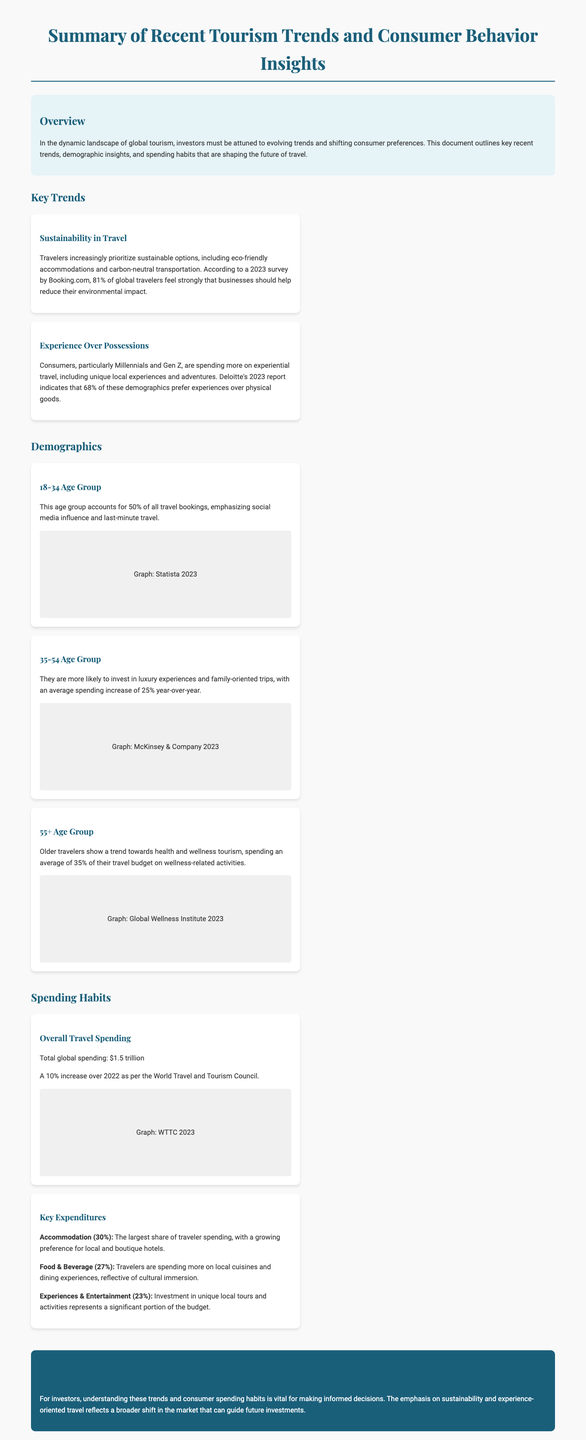What percentage of global travelers prioritize sustainability? According to a 2023 survey, 81% of global travelers feel strongly that businesses should help reduce their environmental impact.
Answer: 81% What age group accounts for 50% of travel bookings? The document states that the 18-34 age group accounts for 50% of all travel bookings.
Answer: 18-34 What is the average spending increase year-over-year for the 35-54 age group? The document mentions that the 35-54 age group has an average spending increase of 25% year-over-year.
Answer: 25% How much is total global spending on travel? The document reports total global spending on travel as $1.5 trillion.
Answer: $1.5 trillion What category accounts for the largest share of traveler spending? The document indicates that accommodation accounts for the largest share of traveler spending at 30%.
Answer: Accommodation (30%) What percentage of the travel budget do older travelers spend on wellness-related activities? The document states that older travelers spend an average of 35% of their travel budget on wellness-related activities.
Answer: 35% Which demographic shows a trend toward experience over possessions? The document highlights Millennials and Gen Z as demographics that prefer experiences over physical goods.
Answer: Millennials and Gen Z What is the key expenditure percentage for experiences and entertainment? The document specifies that experiences and entertainment account for 23% of traveler spending.
Answer: 23% 